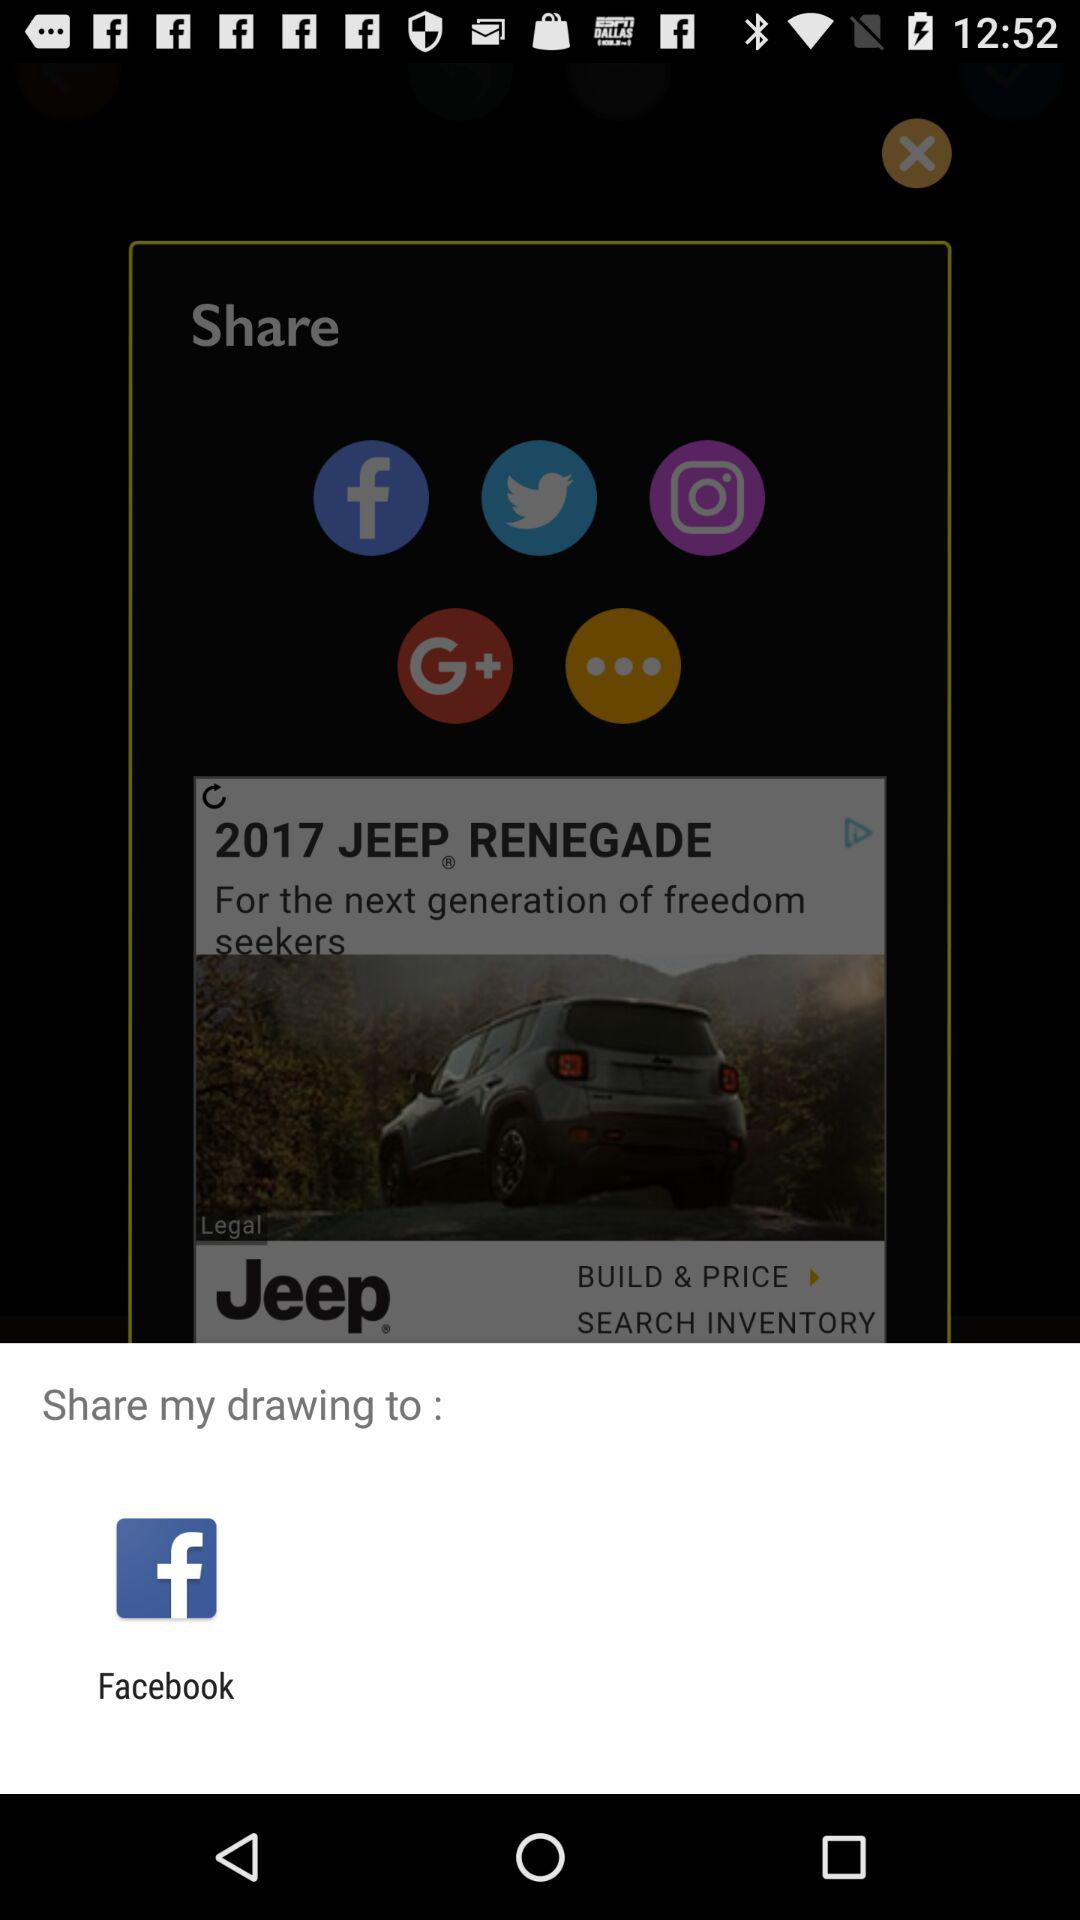What are the sharing options? The sharing options are "Facebook", "Twitter", "Instagram" and "Google+". 